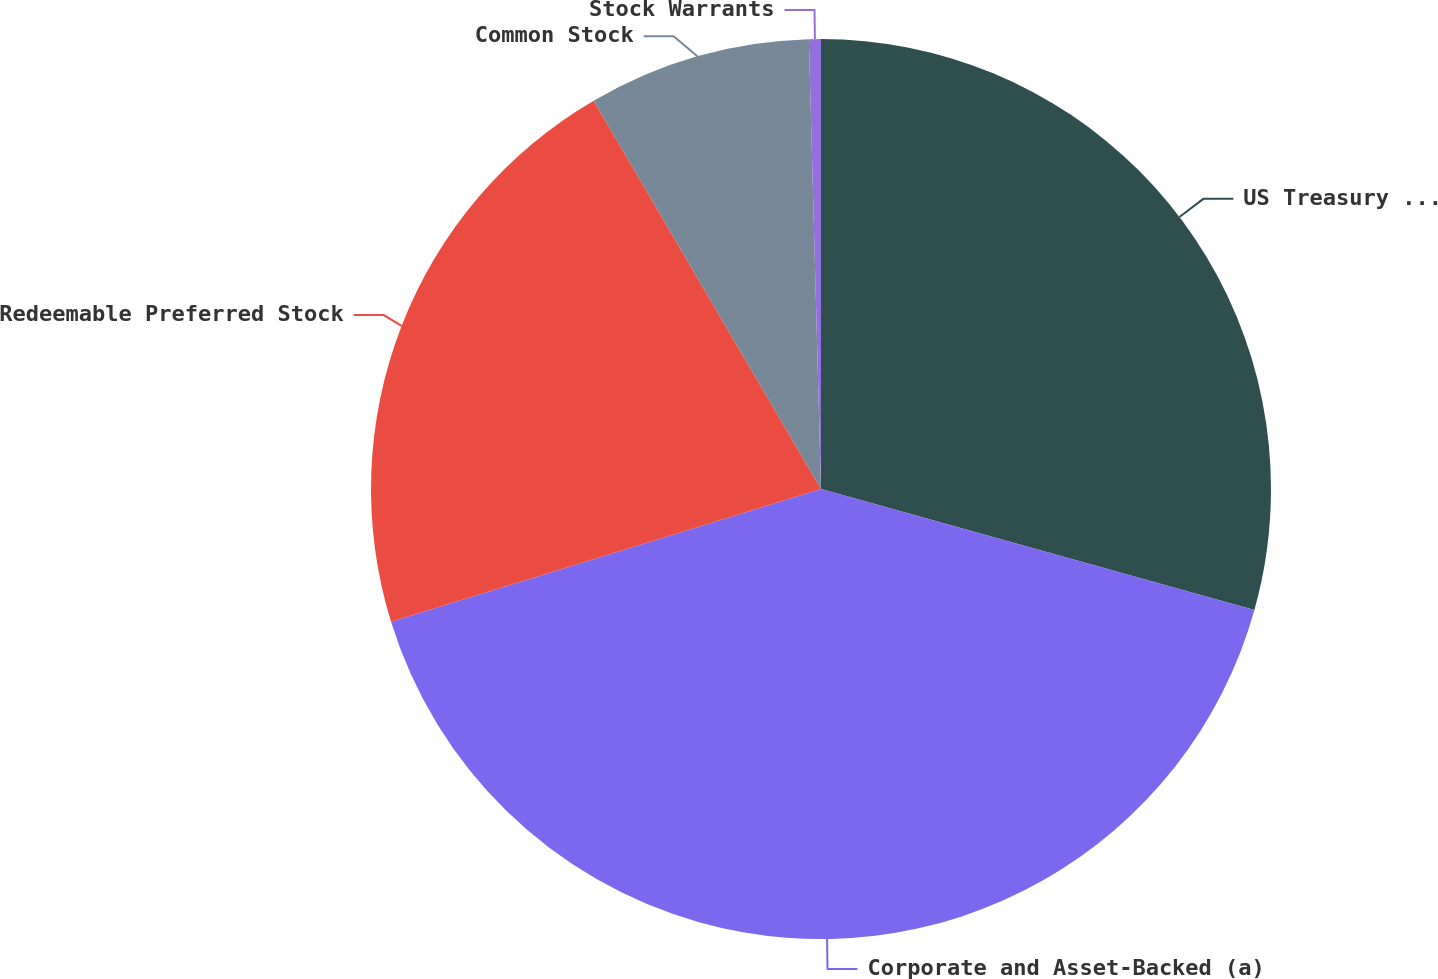Convert chart to OTSL. <chart><loc_0><loc_0><loc_500><loc_500><pie_chart><fcel>US Treasury and Agency<fcel>Corporate and Asset-Backed (a)<fcel>Redeemable Preferred Stock<fcel>Common Stock<fcel>Stock Warrants<nl><fcel>29.34%<fcel>40.9%<fcel>21.34%<fcel>8.0%<fcel>0.43%<nl></chart> 